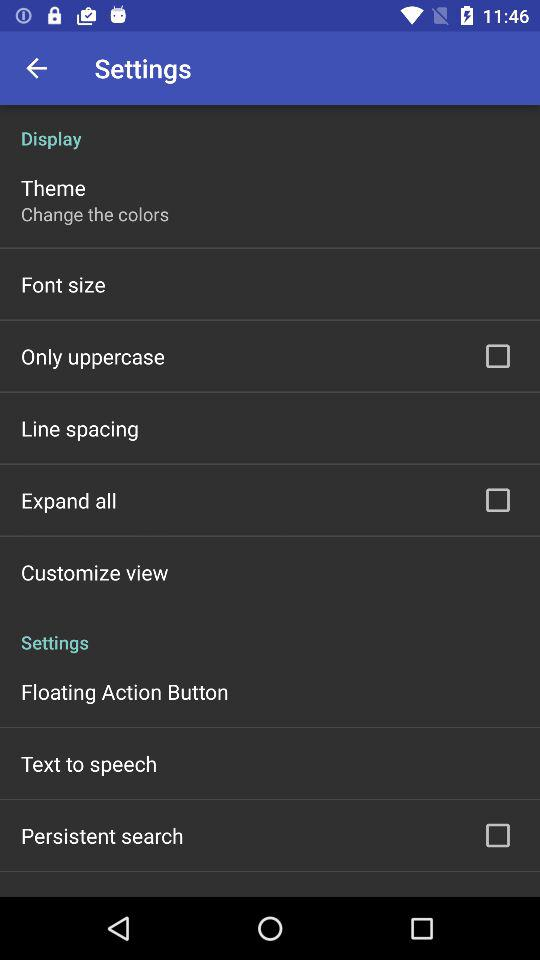What is the status of "Persistent search"? The status is "off". 